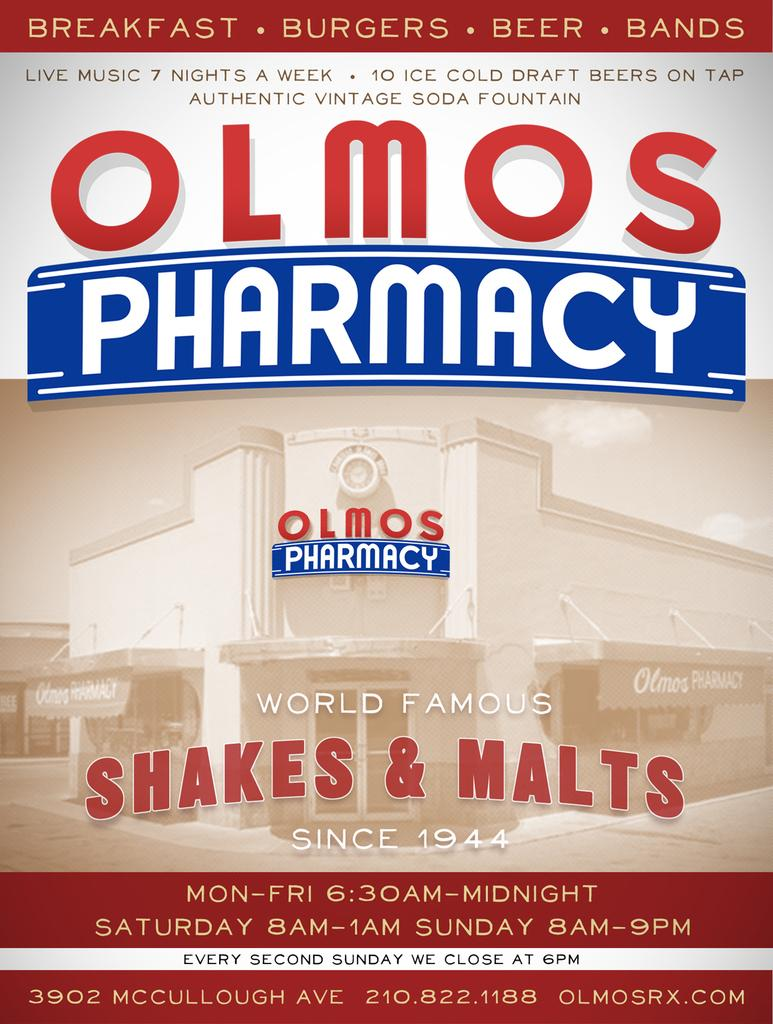What is featured on the poster in the image? The poster contains a picture of a building. What else can be found on the poster besides the image? There is text on the poster. What type of oatmeal is being served on the poster? There is no oatmeal present on the poster; it features a picture of a building and text. What color is the dress worn by the person in the poster? There is no person or dress depicted on the poster; it only contains a picture of a building and text. 